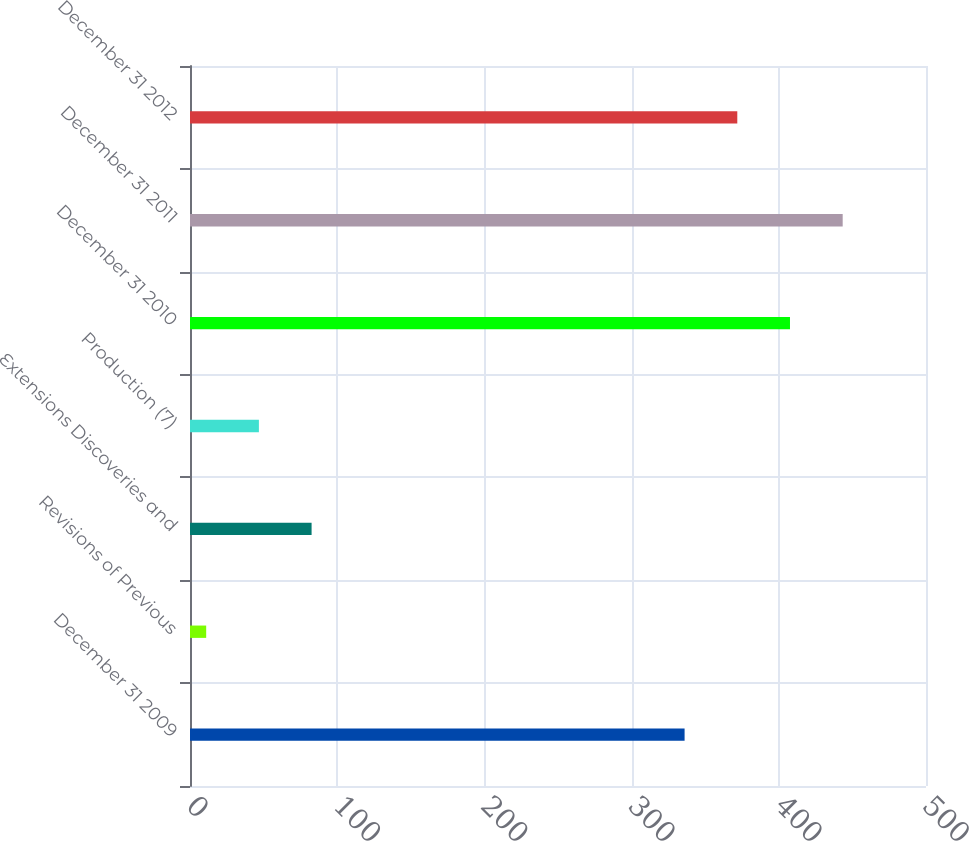Convert chart. <chart><loc_0><loc_0><loc_500><loc_500><bar_chart><fcel>December 31 2009<fcel>Revisions of Previous<fcel>Extensions Discoveries and<fcel>Production (7)<fcel>December 31 2010<fcel>December 31 2011<fcel>December 31 2012<nl><fcel>336<fcel>11<fcel>82.6<fcel>46.8<fcel>407.6<fcel>443.4<fcel>371.8<nl></chart> 